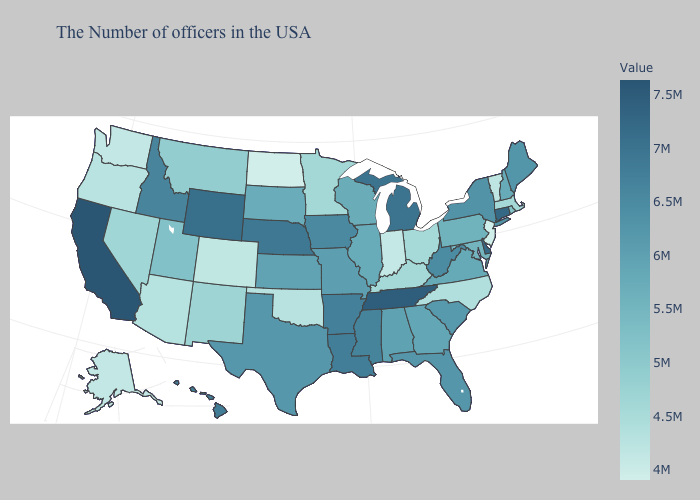Does North Dakota have the lowest value in the USA?
Write a very short answer. Yes. Which states have the highest value in the USA?
Give a very brief answer. California. Does Wisconsin have a lower value than Wyoming?
Keep it brief. Yes. Among the states that border Wyoming , which have the lowest value?
Concise answer only. Colorado. Among the states that border California , which have the lowest value?
Be succinct. Oregon. Among the states that border Tennessee , does Missouri have the lowest value?
Short answer required. No. Does the map have missing data?
Concise answer only. No. Among the states that border Vermont , which have the lowest value?
Keep it brief. Massachusetts. 